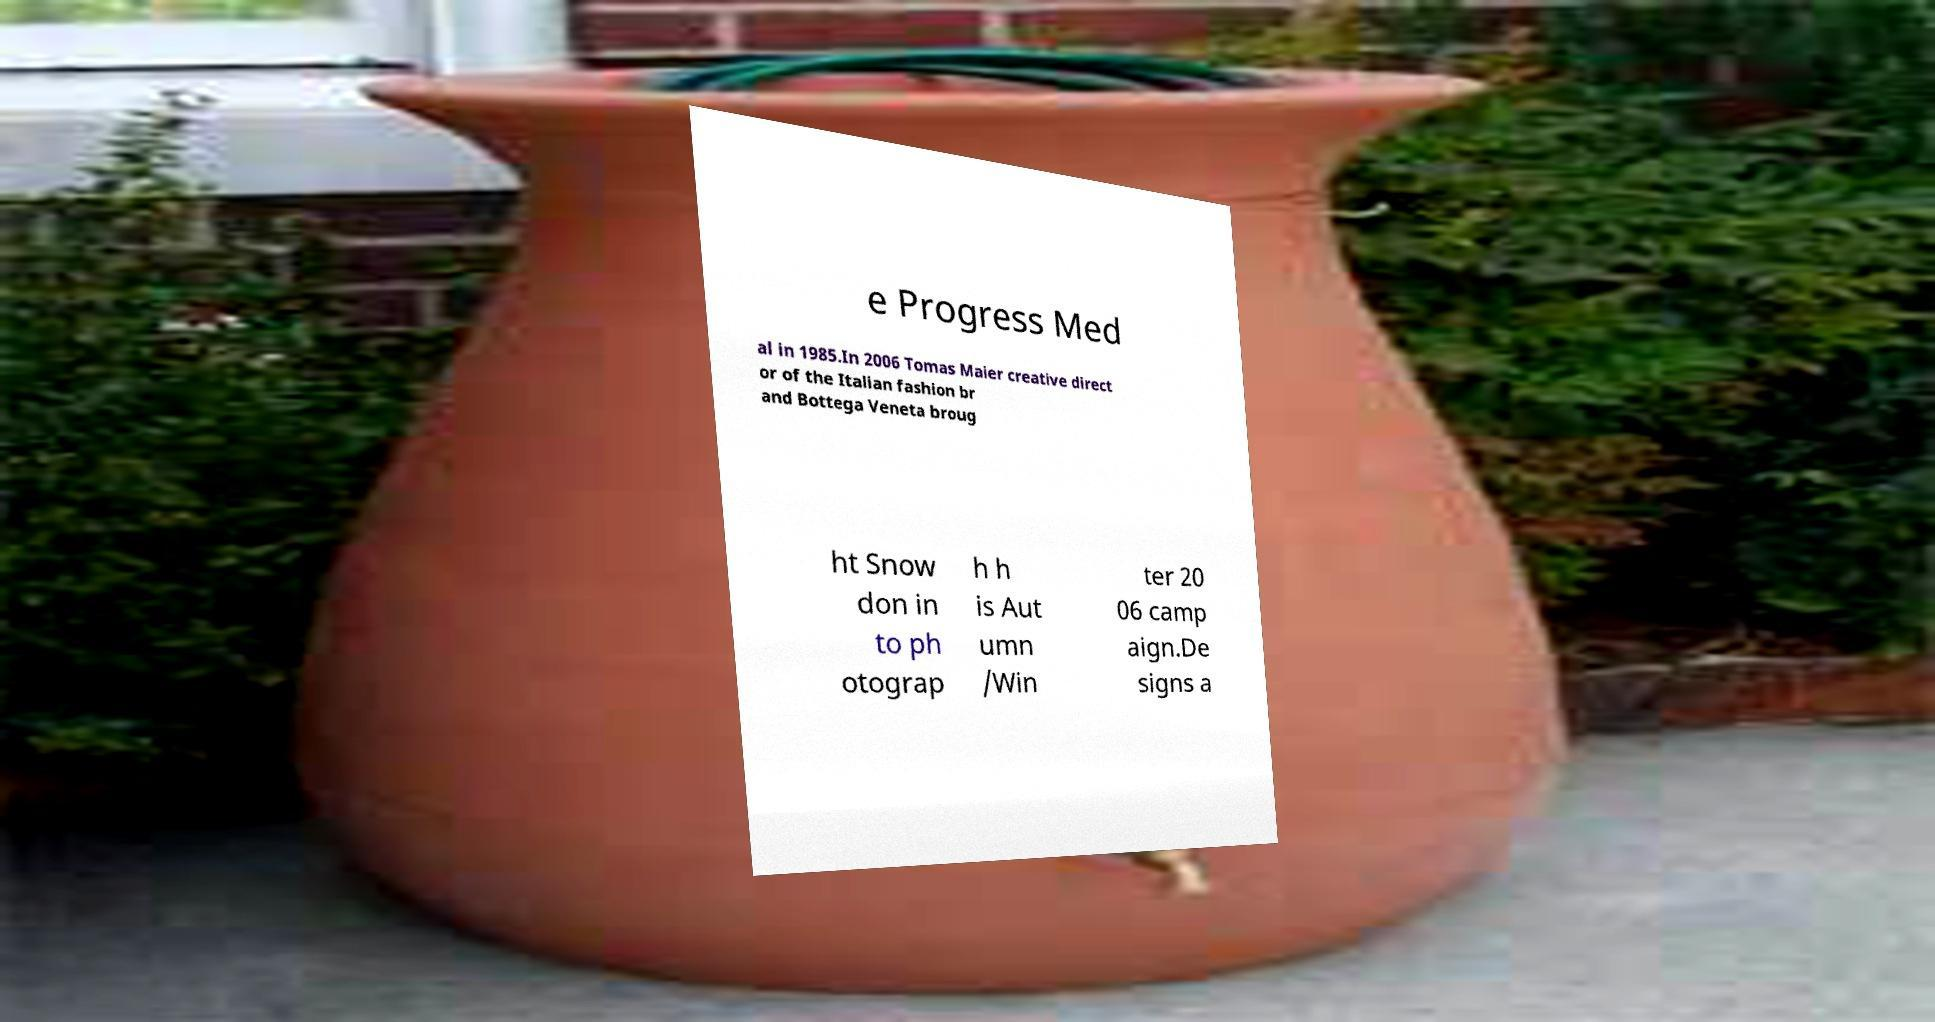Could you assist in decoding the text presented in this image and type it out clearly? e Progress Med al in 1985.In 2006 Tomas Maier creative direct or of the Italian fashion br and Bottega Veneta broug ht Snow don in to ph otograp h h is Aut umn /Win ter 20 06 camp aign.De signs a 